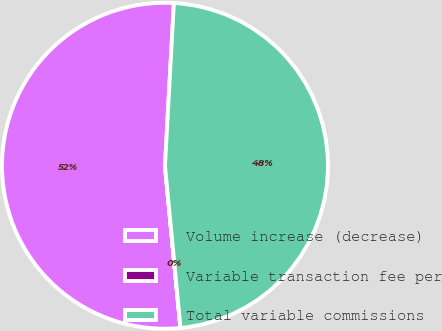Convert chart. <chart><loc_0><loc_0><loc_500><loc_500><pie_chart><fcel>Volume increase (decrease)<fcel>Variable transaction fee per<fcel>Total variable commissions<nl><fcel>52.38%<fcel>0.01%<fcel>47.61%<nl></chart> 